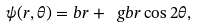<formula> <loc_0><loc_0><loc_500><loc_500>\psi ( r , \theta ) = b r + \ g b r \cos 2 \theta ,</formula> 